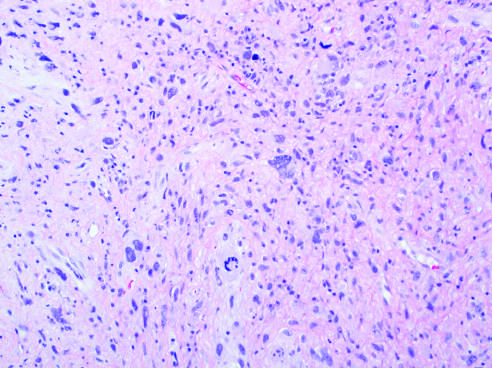what does undifferentiated pleomorphic sarcoma show?
Answer the question using a single word or phrase. Anaplastic spindled to polygonal cells 